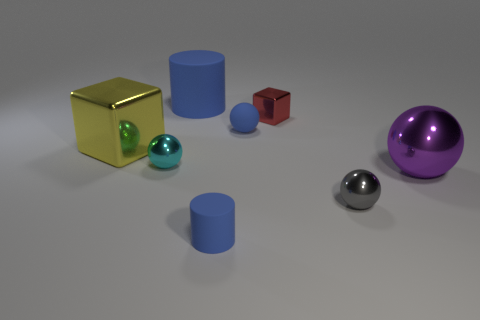Subtract all small cyan metallic balls. How many balls are left? 3 Subtract 4 balls. How many balls are left? 0 Add 1 brown metallic cubes. How many objects exist? 9 Subtract 0 gray cylinders. How many objects are left? 8 Subtract all cylinders. How many objects are left? 6 Subtract all yellow blocks. Subtract all gray cylinders. How many blocks are left? 1 Subtract all gray spheres. How many yellow cubes are left? 1 Subtract all small cyan spheres. Subtract all tiny metallic objects. How many objects are left? 4 Add 8 red objects. How many red objects are left? 9 Add 5 red blocks. How many red blocks exist? 6 